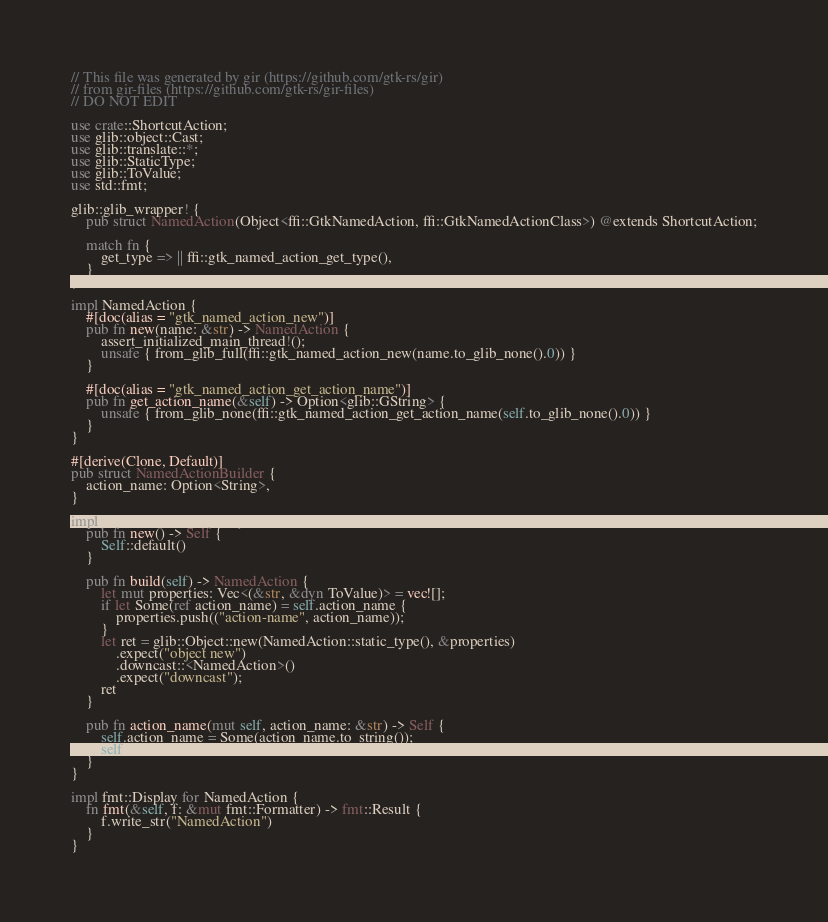<code> <loc_0><loc_0><loc_500><loc_500><_Rust_>// This file was generated by gir (https://github.com/gtk-rs/gir)
// from gir-files (https://github.com/gtk-rs/gir-files)
// DO NOT EDIT

use crate::ShortcutAction;
use glib::object::Cast;
use glib::translate::*;
use glib::StaticType;
use glib::ToValue;
use std::fmt;

glib::glib_wrapper! {
    pub struct NamedAction(Object<ffi::GtkNamedAction, ffi::GtkNamedActionClass>) @extends ShortcutAction;

    match fn {
        get_type => || ffi::gtk_named_action_get_type(),
    }
}

impl NamedAction {
    #[doc(alias = "gtk_named_action_new")]
    pub fn new(name: &str) -> NamedAction {
        assert_initialized_main_thread!();
        unsafe { from_glib_full(ffi::gtk_named_action_new(name.to_glib_none().0)) }
    }

    #[doc(alias = "gtk_named_action_get_action_name")]
    pub fn get_action_name(&self) -> Option<glib::GString> {
        unsafe { from_glib_none(ffi::gtk_named_action_get_action_name(self.to_glib_none().0)) }
    }
}

#[derive(Clone, Default)]
pub struct NamedActionBuilder {
    action_name: Option<String>,
}

impl NamedActionBuilder {
    pub fn new() -> Self {
        Self::default()
    }

    pub fn build(self) -> NamedAction {
        let mut properties: Vec<(&str, &dyn ToValue)> = vec![];
        if let Some(ref action_name) = self.action_name {
            properties.push(("action-name", action_name));
        }
        let ret = glib::Object::new(NamedAction::static_type(), &properties)
            .expect("object new")
            .downcast::<NamedAction>()
            .expect("downcast");
        ret
    }

    pub fn action_name(mut self, action_name: &str) -> Self {
        self.action_name = Some(action_name.to_string());
        self
    }
}

impl fmt::Display for NamedAction {
    fn fmt(&self, f: &mut fmt::Formatter) -> fmt::Result {
        f.write_str("NamedAction")
    }
}
</code> 